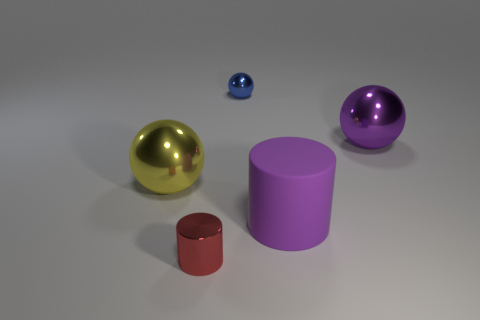What number of large things are the same color as the large cylinder?
Offer a very short reply. 1. How many blue objects are either metallic cubes or spheres?
Provide a succinct answer. 1. What size is the purple object behind the sphere that is in front of the sphere that is right of the tiny blue sphere?
Make the answer very short. Large. What size is the red metal object that is the same shape as the rubber object?
Ensure brevity in your answer.  Small. What number of large things are gray matte objects or blue objects?
Ensure brevity in your answer.  0. Do the tiny thing behind the purple matte thing and the big ball that is to the right of the red metal object have the same material?
Provide a short and direct response. Yes. There is a big object in front of the yellow metallic object; what is it made of?
Your answer should be compact. Rubber. What number of metal things are purple things or small blue spheres?
Provide a short and direct response. 2. What color is the big shiny thing to the left of the matte cylinder that is right of the big yellow metallic ball?
Your response must be concise. Yellow. Is the material of the blue sphere the same as the ball on the left side of the tiny red metallic object?
Your answer should be compact. Yes. 